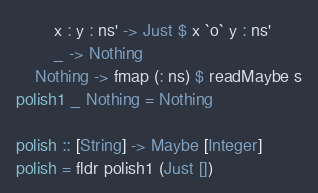Convert code to text. <code><loc_0><loc_0><loc_500><loc_500><_Haskell_>		x : y : ns' -> Just $ x `o` y : ns'
		_ -> Nothing
	Nothing -> fmap (: ns) $ readMaybe s
polish1 _ Nothing = Nothing

polish :: [String] -> Maybe [Integer]
polish = fldr polish1 (Just [])
</code> 